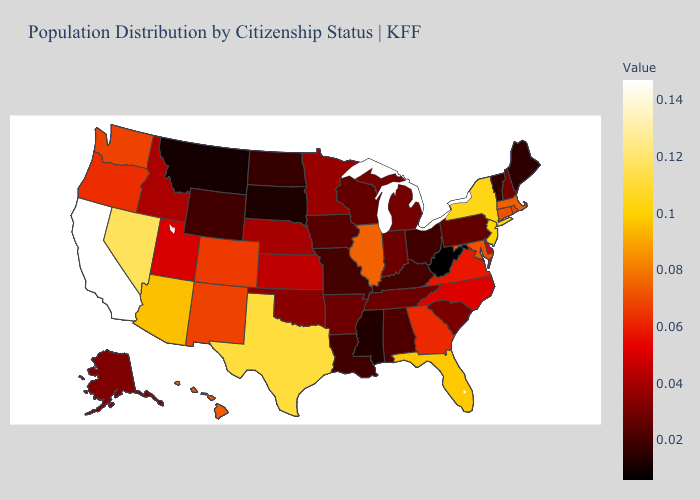Does Texas have the highest value in the South?
Write a very short answer. Yes. Which states have the highest value in the USA?
Answer briefly. California. Among the states that border Ohio , which have the lowest value?
Keep it brief. West Virginia. Does the map have missing data?
Keep it brief. No. Does New York have a lower value than South Dakota?
Keep it brief. No. Which states hav the highest value in the West?
Answer briefly. California. Which states have the lowest value in the South?
Give a very brief answer. West Virginia. 